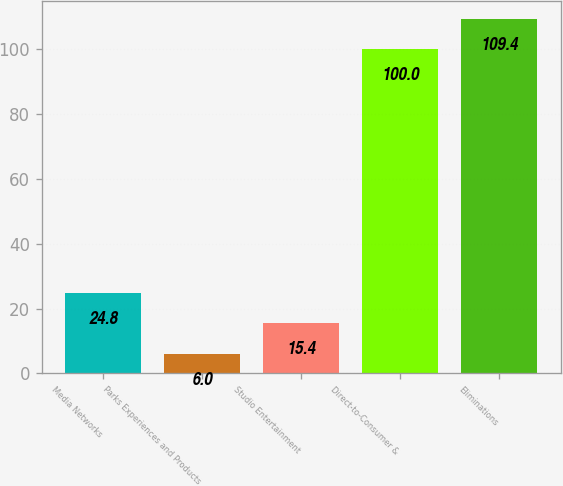Convert chart. <chart><loc_0><loc_0><loc_500><loc_500><bar_chart><fcel>Media Networks<fcel>Parks Experiences and Products<fcel>Studio Entertainment<fcel>Direct-to-Consumer &<fcel>Eliminations<nl><fcel>24.8<fcel>6<fcel>15.4<fcel>100<fcel>109.4<nl></chart> 